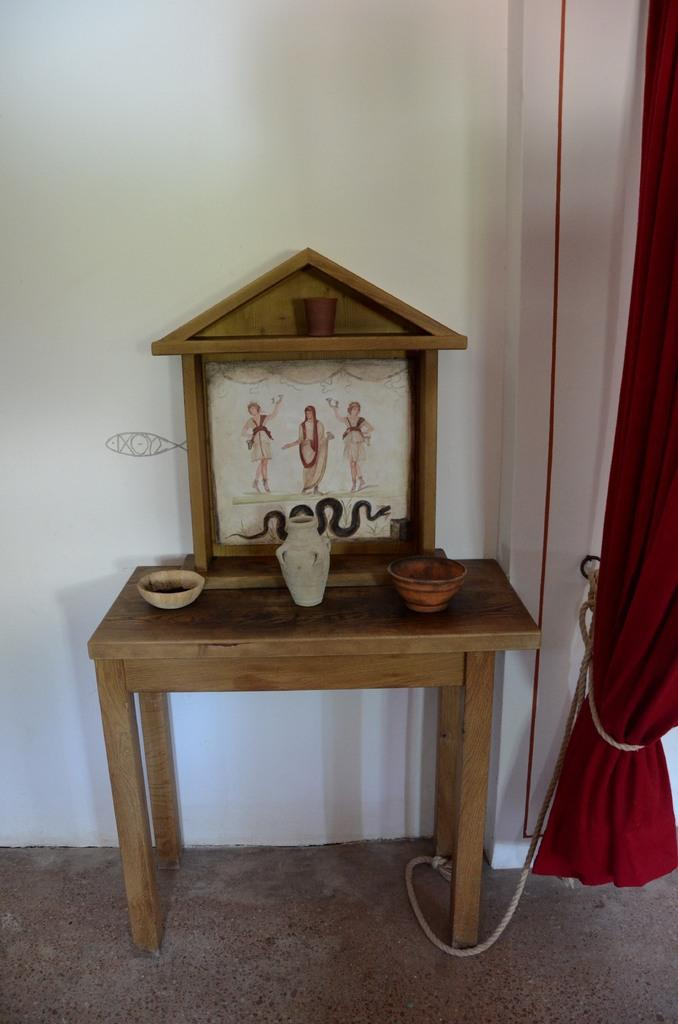What type of object can be seen in the image that typically holds pictures or artwork? There is a frame in the image that typically holds pictures or artwork. What type of container is visible in the image that is often used for holding flowers? There is a vase in the image that is often used for holding flowers. How many bowls are present in the image? There are two bowls in the image. On what surface are the objects placed in the image? The objects are on a wooden table in the image. What type of window treatment is visible in the image? There is a curtain in the image. What can be seen on the left side of the image? There are ropes on the left side of the image. What is visible in the background of the image? There is a wall in the background of the image. What type of machine is visible in the image? There is no machine present in the image. What is the name of the person who created the artwork in the frame? The provided facts do not mention the name of the artist who created the artwork in the frame. 